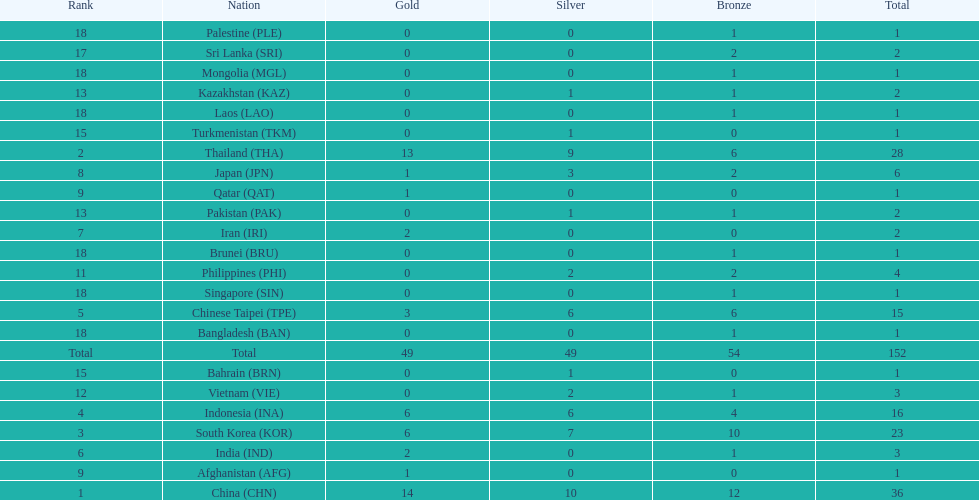Which nation finished first in total medals earned? China (CHN). 